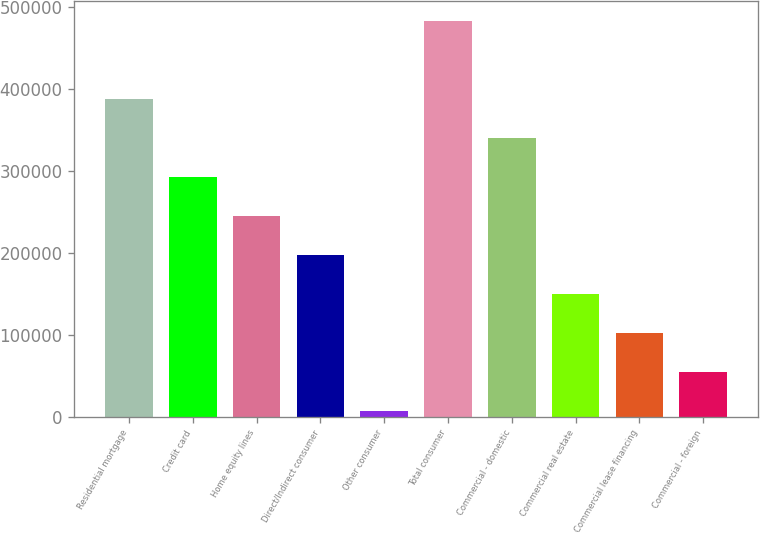<chart> <loc_0><loc_0><loc_500><loc_500><bar_chart><fcel>Residential mortgage<fcel>Credit card<fcel>Home equity lines<fcel>Direct/Indirect consumer<fcel>Other consumer<fcel>Total consumer<fcel>Commercial - domestic<fcel>Commercial real estate<fcel>Commercial lease financing<fcel>Commercial - foreign<nl><fcel>387804<fcel>292782<fcel>245272<fcel>197761<fcel>7717<fcel>482826<fcel>340293<fcel>150250<fcel>102739<fcel>55227.9<nl></chart> 